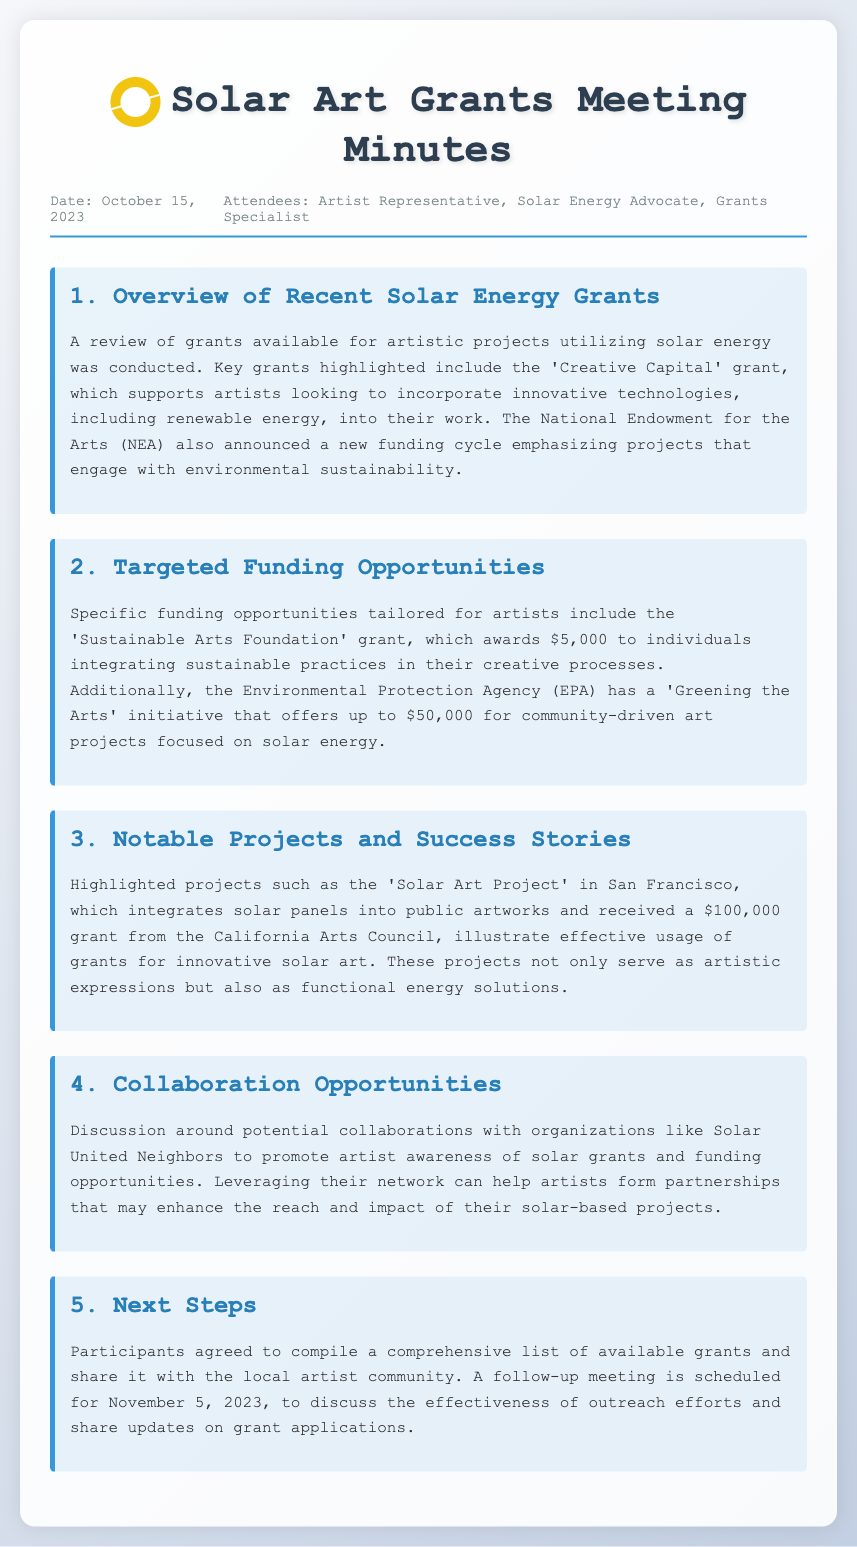What is the date of the meeting? The date of the meeting is noted in the header of the document.
Answer: October 15, 2023 Who is one of the attendees mentioned? The attendees are listed in the header, specifying individuals present at the meeting.
Answer: Artist Representative Which grant supports artists using innovative technologies? The document describes a grant that focuses on incorporating renewable energy into artistic work.
Answer: Creative Capital What is the amount awarded by the Sustainable Arts Foundation grant? The specific funding amount for the grant is provided in the section discussing targeted funding opportunities.
Answer: $5,000 Which project received a $100,000 grant? The document highlights a specific project that received significant funding for its solar art initiative.
Answer: Solar Art Project What organization is mentioned for potential collaboration? A specific organization is suggested for partnerships to enhance awareness of solar grants.
Answer: Solar United Neighbors When is the follow-up meeting scheduled? The next steps include scheduling a follow-up meeting, which is noted in the closing section of the document.
Answer: November 5, 2023 